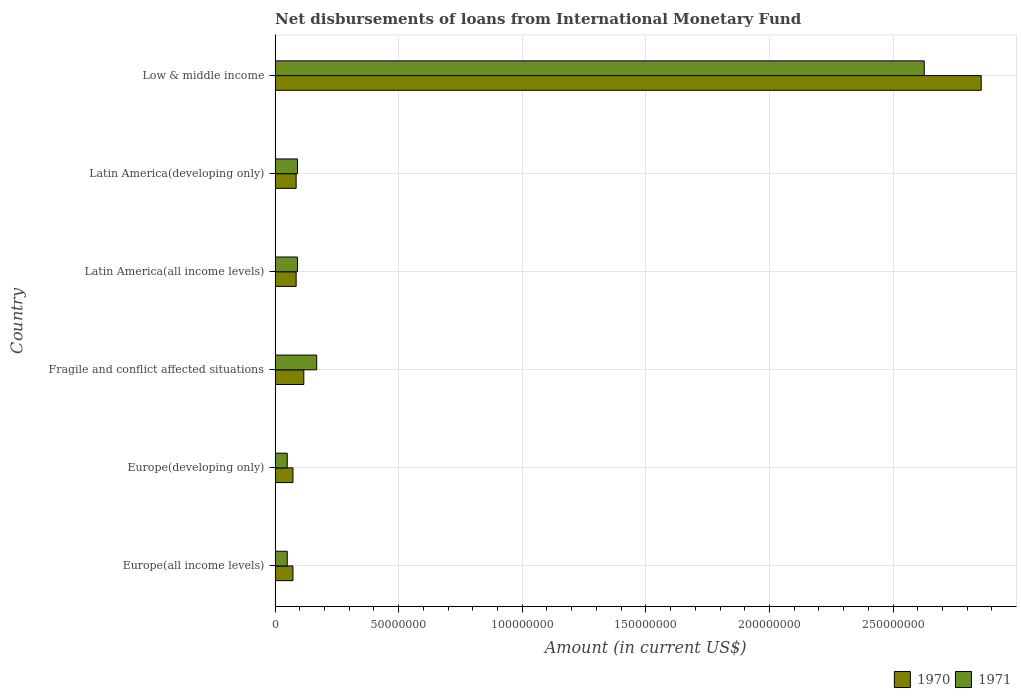How many groups of bars are there?
Provide a short and direct response. 6. How many bars are there on the 2nd tick from the top?
Provide a succinct answer. 2. How many bars are there on the 2nd tick from the bottom?
Your response must be concise. 2. What is the label of the 1st group of bars from the top?
Your answer should be very brief. Low & middle income. What is the amount of loans disbursed in 1971 in Europe(developing only)?
Ensure brevity in your answer.  4.92e+06. Across all countries, what is the maximum amount of loans disbursed in 1970?
Give a very brief answer. 2.86e+08. Across all countries, what is the minimum amount of loans disbursed in 1971?
Make the answer very short. 4.92e+06. In which country was the amount of loans disbursed in 1970 minimum?
Offer a terse response. Europe(all income levels). What is the total amount of loans disbursed in 1971 in the graph?
Offer a very short reply. 3.07e+08. What is the difference between the amount of loans disbursed in 1970 in Europe(developing only) and that in Latin America(developing only)?
Your response must be concise. -1.28e+06. What is the difference between the amount of loans disbursed in 1970 in Fragile and conflict affected situations and the amount of loans disbursed in 1971 in Europe(all income levels)?
Provide a short and direct response. 6.70e+06. What is the average amount of loans disbursed in 1970 per country?
Ensure brevity in your answer.  5.48e+07. What is the difference between the amount of loans disbursed in 1970 and amount of loans disbursed in 1971 in Fragile and conflict affected situations?
Offer a terse response. -5.21e+06. What is the ratio of the amount of loans disbursed in 1971 in Europe(developing only) to that in Low & middle income?
Offer a terse response. 0.02. Is the amount of loans disbursed in 1970 in Latin America(developing only) less than that in Low & middle income?
Offer a terse response. Yes. What is the difference between the highest and the second highest amount of loans disbursed in 1971?
Make the answer very short. 2.46e+08. What is the difference between the highest and the lowest amount of loans disbursed in 1970?
Your answer should be very brief. 2.78e+08. What does the 1st bar from the top in Europe(all income levels) represents?
Offer a very short reply. 1971. How many countries are there in the graph?
Make the answer very short. 6. Does the graph contain grids?
Ensure brevity in your answer.  Yes. How many legend labels are there?
Keep it short and to the point. 2. What is the title of the graph?
Offer a terse response. Net disbursements of loans from International Monetary Fund. Does "1996" appear as one of the legend labels in the graph?
Give a very brief answer. No. What is the label or title of the X-axis?
Keep it short and to the point. Amount (in current US$). What is the Amount (in current US$) in 1970 in Europe(all income levels)?
Your response must be concise. 7.23e+06. What is the Amount (in current US$) in 1971 in Europe(all income levels)?
Make the answer very short. 4.92e+06. What is the Amount (in current US$) in 1970 in Europe(developing only)?
Provide a succinct answer. 7.23e+06. What is the Amount (in current US$) in 1971 in Europe(developing only)?
Your response must be concise. 4.92e+06. What is the Amount (in current US$) of 1970 in Fragile and conflict affected situations?
Your answer should be very brief. 1.16e+07. What is the Amount (in current US$) of 1971 in Fragile and conflict affected situations?
Your answer should be very brief. 1.68e+07. What is the Amount (in current US$) of 1970 in Latin America(all income levels)?
Offer a terse response. 8.52e+06. What is the Amount (in current US$) of 1971 in Latin America(all income levels)?
Make the answer very short. 9.06e+06. What is the Amount (in current US$) of 1970 in Latin America(developing only)?
Your answer should be very brief. 8.52e+06. What is the Amount (in current US$) of 1971 in Latin America(developing only)?
Offer a very short reply. 9.06e+06. What is the Amount (in current US$) of 1970 in Low & middle income?
Your answer should be compact. 2.86e+08. What is the Amount (in current US$) in 1971 in Low & middle income?
Provide a succinct answer. 2.63e+08. Across all countries, what is the maximum Amount (in current US$) of 1970?
Provide a succinct answer. 2.86e+08. Across all countries, what is the maximum Amount (in current US$) in 1971?
Your answer should be compact. 2.63e+08. Across all countries, what is the minimum Amount (in current US$) in 1970?
Your response must be concise. 7.23e+06. Across all countries, what is the minimum Amount (in current US$) in 1971?
Make the answer very short. 4.92e+06. What is the total Amount (in current US$) in 1970 in the graph?
Offer a terse response. 3.29e+08. What is the total Amount (in current US$) in 1971 in the graph?
Your answer should be compact. 3.07e+08. What is the difference between the Amount (in current US$) in 1970 in Europe(all income levels) and that in Fragile and conflict affected situations?
Give a very brief answer. -4.39e+06. What is the difference between the Amount (in current US$) of 1971 in Europe(all income levels) and that in Fragile and conflict affected situations?
Your answer should be compact. -1.19e+07. What is the difference between the Amount (in current US$) of 1970 in Europe(all income levels) and that in Latin America(all income levels)?
Your response must be concise. -1.28e+06. What is the difference between the Amount (in current US$) in 1971 in Europe(all income levels) and that in Latin America(all income levels)?
Provide a succinct answer. -4.14e+06. What is the difference between the Amount (in current US$) of 1970 in Europe(all income levels) and that in Latin America(developing only)?
Your response must be concise. -1.28e+06. What is the difference between the Amount (in current US$) of 1971 in Europe(all income levels) and that in Latin America(developing only)?
Ensure brevity in your answer.  -4.14e+06. What is the difference between the Amount (in current US$) of 1970 in Europe(all income levels) and that in Low & middle income?
Provide a short and direct response. -2.78e+08. What is the difference between the Amount (in current US$) of 1971 in Europe(all income levels) and that in Low & middle income?
Your response must be concise. -2.58e+08. What is the difference between the Amount (in current US$) in 1970 in Europe(developing only) and that in Fragile and conflict affected situations?
Provide a short and direct response. -4.39e+06. What is the difference between the Amount (in current US$) in 1971 in Europe(developing only) and that in Fragile and conflict affected situations?
Your answer should be very brief. -1.19e+07. What is the difference between the Amount (in current US$) in 1970 in Europe(developing only) and that in Latin America(all income levels)?
Keep it short and to the point. -1.28e+06. What is the difference between the Amount (in current US$) of 1971 in Europe(developing only) and that in Latin America(all income levels)?
Offer a very short reply. -4.14e+06. What is the difference between the Amount (in current US$) in 1970 in Europe(developing only) and that in Latin America(developing only)?
Offer a very short reply. -1.28e+06. What is the difference between the Amount (in current US$) of 1971 in Europe(developing only) and that in Latin America(developing only)?
Your answer should be compact. -4.14e+06. What is the difference between the Amount (in current US$) in 1970 in Europe(developing only) and that in Low & middle income?
Give a very brief answer. -2.78e+08. What is the difference between the Amount (in current US$) in 1971 in Europe(developing only) and that in Low & middle income?
Offer a very short reply. -2.58e+08. What is the difference between the Amount (in current US$) of 1970 in Fragile and conflict affected situations and that in Latin America(all income levels)?
Offer a terse response. 3.10e+06. What is the difference between the Amount (in current US$) of 1971 in Fragile and conflict affected situations and that in Latin America(all income levels)?
Give a very brief answer. 7.77e+06. What is the difference between the Amount (in current US$) in 1970 in Fragile and conflict affected situations and that in Latin America(developing only)?
Make the answer very short. 3.10e+06. What is the difference between the Amount (in current US$) in 1971 in Fragile and conflict affected situations and that in Latin America(developing only)?
Provide a short and direct response. 7.77e+06. What is the difference between the Amount (in current US$) of 1970 in Fragile and conflict affected situations and that in Low & middle income?
Make the answer very short. -2.74e+08. What is the difference between the Amount (in current US$) in 1971 in Fragile and conflict affected situations and that in Low & middle income?
Keep it short and to the point. -2.46e+08. What is the difference between the Amount (in current US$) of 1970 in Latin America(all income levels) and that in Low & middle income?
Provide a succinct answer. -2.77e+08. What is the difference between the Amount (in current US$) in 1971 in Latin America(all income levels) and that in Low & middle income?
Your answer should be compact. -2.54e+08. What is the difference between the Amount (in current US$) of 1970 in Latin America(developing only) and that in Low & middle income?
Your answer should be compact. -2.77e+08. What is the difference between the Amount (in current US$) of 1971 in Latin America(developing only) and that in Low & middle income?
Ensure brevity in your answer.  -2.54e+08. What is the difference between the Amount (in current US$) in 1970 in Europe(all income levels) and the Amount (in current US$) in 1971 in Europe(developing only)?
Provide a succinct answer. 2.31e+06. What is the difference between the Amount (in current US$) in 1970 in Europe(all income levels) and the Amount (in current US$) in 1971 in Fragile and conflict affected situations?
Provide a short and direct response. -9.60e+06. What is the difference between the Amount (in current US$) of 1970 in Europe(all income levels) and the Amount (in current US$) of 1971 in Latin America(all income levels)?
Make the answer very short. -1.83e+06. What is the difference between the Amount (in current US$) of 1970 in Europe(all income levels) and the Amount (in current US$) of 1971 in Latin America(developing only)?
Offer a terse response. -1.83e+06. What is the difference between the Amount (in current US$) of 1970 in Europe(all income levels) and the Amount (in current US$) of 1971 in Low & middle income?
Make the answer very short. -2.55e+08. What is the difference between the Amount (in current US$) of 1970 in Europe(developing only) and the Amount (in current US$) of 1971 in Fragile and conflict affected situations?
Provide a succinct answer. -9.60e+06. What is the difference between the Amount (in current US$) of 1970 in Europe(developing only) and the Amount (in current US$) of 1971 in Latin America(all income levels)?
Provide a short and direct response. -1.83e+06. What is the difference between the Amount (in current US$) in 1970 in Europe(developing only) and the Amount (in current US$) in 1971 in Latin America(developing only)?
Make the answer very short. -1.83e+06. What is the difference between the Amount (in current US$) of 1970 in Europe(developing only) and the Amount (in current US$) of 1971 in Low & middle income?
Offer a very short reply. -2.55e+08. What is the difference between the Amount (in current US$) of 1970 in Fragile and conflict affected situations and the Amount (in current US$) of 1971 in Latin America(all income levels)?
Offer a very short reply. 2.56e+06. What is the difference between the Amount (in current US$) in 1970 in Fragile and conflict affected situations and the Amount (in current US$) in 1971 in Latin America(developing only)?
Offer a very short reply. 2.56e+06. What is the difference between the Amount (in current US$) of 1970 in Fragile and conflict affected situations and the Amount (in current US$) of 1971 in Low & middle income?
Keep it short and to the point. -2.51e+08. What is the difference between the Amount (in current US$) in 1970 in Latin America(all income levels) and the Amount (in current US$) in 1971 in Latin America(developing only)?
Make the answer very short. -5.44e+05. What is the difference between the Amount (in current US$) of 1970 in Latin America(all income levels) and the Amount (in current US$) of 1971 in Low & middle income?
Keep it short and to the point. -2.54e+08. What is the difference between the Amount (in current US$) of 1970 in Latin America(developing only) and the Amount (in current US$) of 1971 in Low & middle income?
Keep it short and to the point. -2.54e+08. What is the average Amount (in current US$) in 1970 per country?
Offer a very short reply. 5.48e+07. What is the average Amount (in current US$) of 1971 per country?
Your answer should be very brief. 5.12e+07. What is the difference between the Amount (in current US$) in 1970 and Amount (in current US$) in 1971 in Europe(all income levels)?
Your response must be concise. 2.31e+06. What is the difference between the Amount (in current US$) in 1970 and Amount (in current US$) in 1971 in Europe(developing only)?
Offer a terse response. 2.31e+06. What is the difference between the Amount (in current US$) in 1970 and Amount (in current US$) in 1971 in Fragile and conflict affected situations?
Provide a succinct answer. -5.21e+06. What is the difference between the Amount (in current US$) of 1970 and Amount (in current US$) of 1971 in Latin America(all income levels)?
Offer a very short reply. -5.44e+05. What is the difference between the Amount (in current US$) of 1970 and Amount (in current US$) of 1971 in Latin America(developing only)?
Your answer should be very brief. -5.44e+05. What is the difference between the Amount (in current US$) of 1970 and Amount (in current US$) of 1971 in Low & middle income?
Provide a succinct answer. 2.30e+07. What is the ratio of the Amount (in current US$) of 1970 in Europe(all income levels) to that in Europe(developing only)?
Offer a terse response. 1. What is the ratio of the Amount (in current US$) of 1971 in Europe(all income levels) to that in Europe(developing only)?
Your response must be concise. 1. What is the ratio of the Amount (in current US$) in 1970 in Europe(all income levels) to that in Fragile and conflict affected situations?
Keep it short and to the point. 0.62. What is the ratio of the Amount (in current US$) of 1971 in Europe(all income levels) to that in Fragile and conflict affected situations?
Provide a succinct answer. 0.29. What is the ratio of the Amount (in current US$) of 1970 in Europe(all income levels) to that in Latin America(all income levels)?
Your answer should be very brief. 0.85. What is the ratio of the Amount (in current US$) of 1971 in Europe(all income levels) to that in Latin America(all income levels)?
Offer a terse response. 0.54. What is the ratio of the Amount (in current US$) in 1970 in Europe(all income levels) to that in Latin America(developing only)?
Provide a short and direct response. 0.85. What is the ratio of the Amount (in current US$) of 1971 in Europe(all income levels) to that in Latin America(developing only)?
Keep it short and to the point. 0.54. What is the ratio of the Amount (in current US$) of 1970 in Europe(all income levels) to that in Low & middle income?
Offer a very short reply. 0.03. What is the ratio of the Amount (in current US$) in 1971 in Europe(all income levels) to that in Low & middle income?
Offer a very short reply. 0.02. What is the ratio of the Amount (in current US$) of 1970 in Europe(developing only) to that in Fragile and conflict affected situations?
Your answer should be very brief. 0.62. What is the ratio of the Amount (in current US$) of 1971 in Europe(developing only) to that in Fragile and conflict affected situations?
Make the answer very short. 0.29. What is the ratio of the Amount (in current US$) in 1970 in Europe(developing only) to that in Latin America(all income levels)?
Your response must be concise. 0.85. What is the ratio of the Amount (in current US$) of 1971 in Europe(developing only) to that in Latin America(all income levels)?
Provide a succinct answer. 0.54. What is the ratio of the Amount (in current US$) in 1970 in Europe(developing only) to that in Latin America(developing only)?
Offer a very short reply. 0.85. What is the ratio of the Amount (in current US$) of 1971 in Europe(developing only) to that in Latin America(developing only)?
Provide a short and direct response. 0.54. What is the ratio of the Amount (in current US$) of 1970 in Europe(developing only) to that in Low & middle income?
Your response must be concise. 0.03. What is the ratio of the Amount (in current US$) of 1971 in Europe(developing only) to that in Low & middle income?
Keep it short and to the point. 0.02. What is the ratio of the Amount (in current US$) of 1970 in Fragile and conflict affected situations to that in Latin America(all income levels)?
Your response must be concise. 1.36. What is the ratio of the Amount (in current US$) in 1971 in Fragile and conflict affected situations to that in Latin America(all income levels)?
Your response must be concise. 1.86. What is the ratio of the Amount (in current US$) of 1970 in Fragile and conflict affected situations to that in Latin America(developing only)?
Your response must be concise. 1.36. What is the ratio of the Amount (in current US$) in 1971 in Fragile and conflict affected situations to that in Latin America(developing only)?
Your answer should be very brief. 1.86. What is the ratio of the Amount (in current US$) of 1970 in Fragile and conflict affected situations to that in Low & middle income?
Provide a short and direct response. 0.04. What is the ratio of the Amount (in current US$) in 1971 in Fragile and conflict affected situations to that in Low & middle income?
Keep it short and to the point. 0.06. What is the ratio of the Amount (in current US$) of 1970 in Latin America(all income levels) to that in Latin America(developing only)?
Offer a very short reply. 1. What is the ratio of the Amount (in current US$) of 1971 in Latin America(all income levels) to that in Latin America(developing only)?
Offer a very short reply. 1. What is the ratio of the Amount (in current US$) of 1970 in Latin America(all income levels) to that in Low & middle income?
Keep it short and to the point. 0.03. What is the ratio of the Amount (in current US$) in 1971 in Latin America(all income levels) to that in Low & middle income?
Your answer should be compact. 0.03. What is the ratio of the Amount (in current US$) of 1970 in Latin America(developing only) to that in Low & middle income?
Your answer should be compact. 0.03. What is the ratio of the Amount (in current US$) of 1971 in Latin America(developing only) to that in Low & middle income?
Your answer should be compact. 0.03. What is the difference between the highest and the second highest Amount (in current US$) in 1970?
Provide a short and direct response. 2.74e+08. What is the difference between the highest and the second highest Amount (in current US$) of 1971?
Ensure brevity in your answer.  2.46e+08. What is the difference between the highest and the lowest Amount (in current US$) in 1970?
Ensure brevity in your answer.  2.78e+08. What is the difference between the highest and the lowest Amount (in current US$) of 1971?
Your response must be concise. 2.58e+08. 